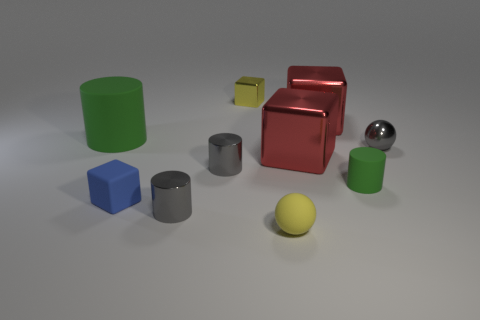Subtract all green blocks. How many green cylinders are left? 2 Subtract all yellow blocks. How many blocks are left? 3 Subtract all tiny rubber cylinders. How many cylinders are left? 3 Subtract 1 blocks. How many blocks are left? 3 Subtract all spheres. How many objects are left? 8 Subtract all green blocks. Subtract all purple balls. How many blocks are left? 4 Subtract all big cubes. Subtract all tiny yellow balls. How many objects are left? 7 Add 8 large rubber cylinders. How many large rubber cylinders are left? 9 Add 4 balls. How many balls exist? 6 Subtract 1 gray balls. How many objects are left? 9 